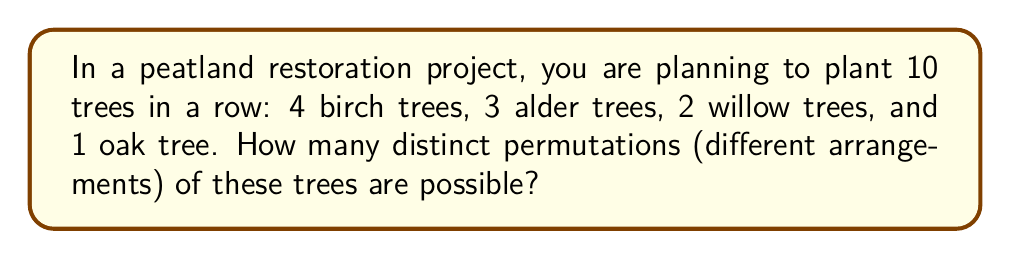What is the answer to this math problem? To solve this problem, we need to use the concept of permutations with repetition from group theory. The formula for the number of permutations with repetition is:

$$\frac{n!}{n_1! \cdot n_2! \cdot ... \cdot n_k!}$$

Where:
- $n$ is the total number of items
- $n_1, n_2, ..., n_k$ are the numbers of each type of item

In this case:
- Total number of trees: $n = 10$
- Number of birch trees: $n_1 = 4$
- Number of alder trees: $n_2 = 3$
- Number of willow trees: $n_3 = 2$
- Number of oak trees: $n_4 = 1$

Let's substitute these values into the formula:

$$\text{Number of permutations} = \frac{10!}{4! \cdot 3! \cdot 2! \cdot 1!}$$

Now, let's calculate step by step:

1) $10! = 3,628,800$
2) $4! = 24$
3) $3! = 6$
4) $2! = 2$
5) $1! = 1$

Substituting these values:

$$\frac{3,628,800}{24 \cdot 6 \cdot 2 \cdot 1} = \frac{3,628,800}{288}$$

Simplifying:

$$\frac{3,628,800}{288} = 12,600$$

Therefore, there are 12,600 distinct permutations possible for planting these trees.
Answer: 12,600 distinct permutations 